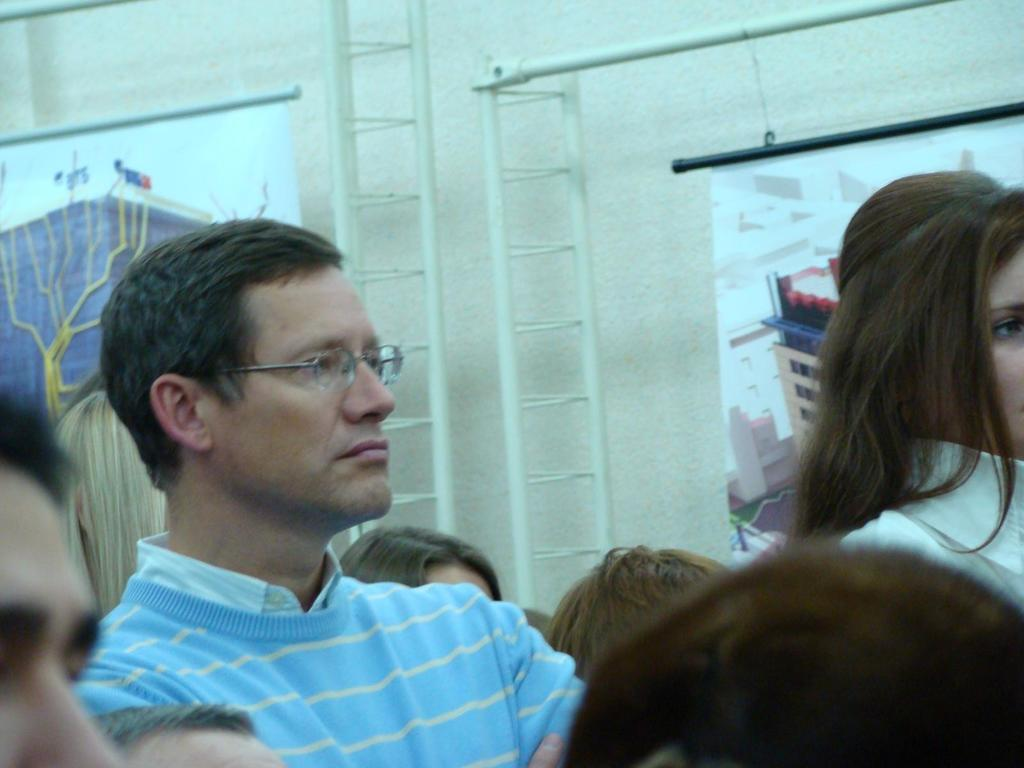How many people are in the foreground of the picture? There are many people in the foreground of the picture. What can be seen in the middle of the picture? There is an iron framed object, posters, and other objects in the middle of the picture. What is visible in the background of the picture? There is a wall in the background of the picture. What type of pizzas can be seen on the flesh during the feast in the image? There is no mention of pizzas, flesh, or a feast in the image; it features many people, an iron framed object, posters, and other objects in the middle, and a wall in the background. 